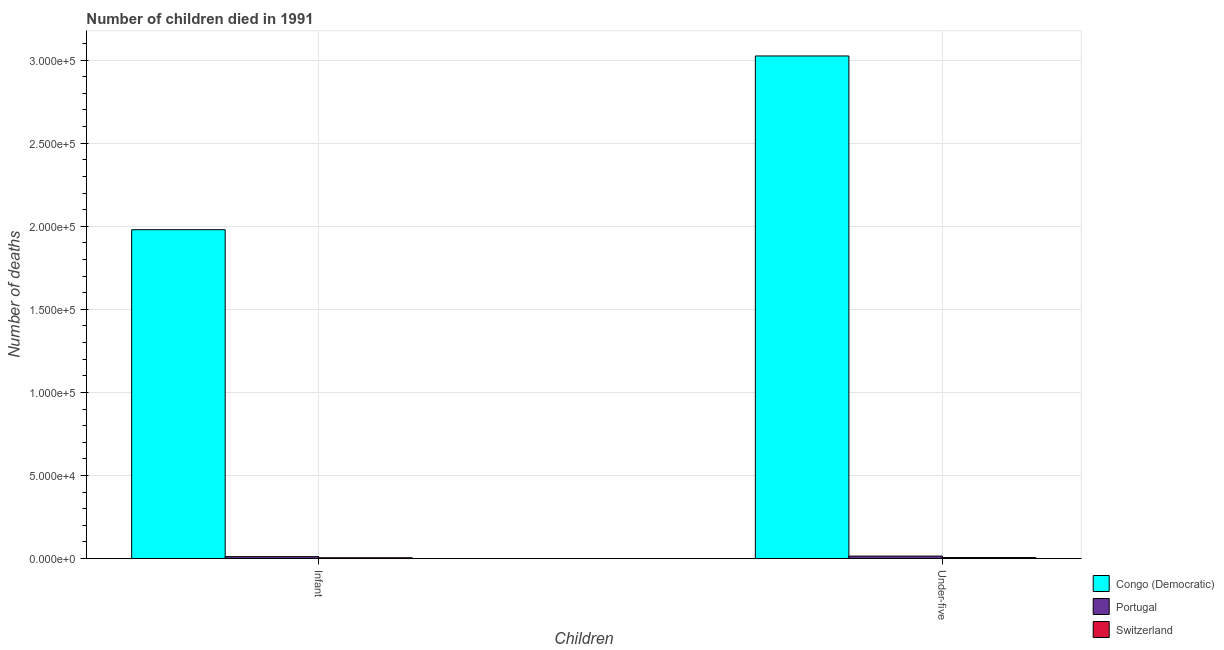How many different coloured bars are there?
Keep it short and to the point. 3. Are the number of bars on each tick of the X-axis equal?
Offer a very short reply. Yes. How many bars are there on the 1st tick from the left?
Provide a short and direct response. 3. How many bars are there on the 2nd tick from the right?
Make the answer very short. 3. What is the label of the 2nd group of bars from the left?
Your response must be concise. Under-five. What is the number of infant deaths in Switzerland?
Your response must be concise. 493. Across all countries, what is the maximum number of under-five deaths?
Provide a short and direct response. 3.03e+05. Across all countries, what is the minimum number of infant deaths?
Offer a terse response. 493. In which country was the number of under-five deaths maximum?
Give a very brief answer. Congo (Democratic). In which country was the number of under-five deaths minimum?
Your answer should be very brief. Switzerland. What is the total number of infant deaths in the graph?
Your answer should be compact. 2.00e+05. What is the difference between the number of infant deaths in Portugal and that in Congo (Democratic)?
Ensure brevity in your answer.  -1.97e+05. What is the difference between the number of under-five deaths in Congo (Democratic) and the number of infant deaths in Portugal?
Your answer should be compact. 3.01e+05. What is the average number of infant deaths per country?
Your answer should be very brief. 6.65e+04. What is the difference between the number of under-five deaths and number of infant deaths in Portugal?
Offer a terse response. 338. What is the ratio of the number of infant deaths in Portugal to that in Switzerland?
Offer a terse response. 2.34. Is the number of infant deaths in Portugal less than that in Switzerland?
Your answer should be very brief. No. In how many countries, is the number of infant deaths greater than the average number of infant deaths taken over all countries?
Offer a terse response. 1. What does the 1st bar from the right in Infant represents?
Your response must be concise. Switzerland. Are all the bars in the graph horizontal?
Your answer should be compact. No. Are the values on the major ticks of Y-axis written in scientific E-notation?
Provide a short and direct response. Yes. Does the graph contain grids?
Ensure brevity in your answer.  Yes. Where does the legend appear in the graph?
Make the answer very short. Bottom right. How many legend labels are there?
Ensure brevity in your answer.  3. What is the title of the graph?
Your response must be concise. Number of children died in 1991. What is the label or title of the X-axis?
Provide a short and direct response. Children. What is the label or title of the Y-axis?
Provide a short and direct response. Number of deaths. What is the Number of deaths in Congo (Democratic) in Infant?
Offer a very short reply. 1.98e+05. What is the Number of deaths in Portugal in Infant?
Your answer should be compact. 1156. What is the Number of deaths in Switzerland in Infant?
Offer a terse response. 493. What is the Number of deaths of Congo (Democratic) in Under-five?
Give a very brief answer. 3.03e+05. What is the Number of deaths in Portugal in Under-five?
Your answer should be very brief. 1494. What is the Number of deaths of Switzerland in Under-five?
Your answer should be very brief. 611. Across all Children, what is the maximum Number of deaths of Congo (Democratic)?
Keep it short and to the point. 3.03e+05. Across all Children, what is the maximum Number of deaths of Portugal?
Your answer should be very brief. 1494. Across all Children, what is the maximum Number of deaths of Switzerland?
Your response must be concise. 611. Across all Children, what is the minimum Number of deaths in Congo (Democratic)?
Your response must be concise. 1.98e+05. Across all Children, what is the minimum Number of deaths in Portugal?
Ensure brevity in your answer.  1156. Across all Children, what is the minimum Number of deaths of Switzerland?
Your answer should be compact. 493. What is the total Number of deaths in Congo (Democratic) in the graph?
Your answer should be very brief. 5.00e+05. What is the total Number of deaths in Portugal in the graph?
Your response must be concise. 2650. What is the total Number of deaths in Switzerland in the graph?
Your response must be concise. 1104. What is the difference between the Number of deaths in Congo (Democratic) in Infant and that in Under-five?
Give a very brief answer. -1.05e+05. What is the difference between the Number of deaths of Portugal in Infant and that in Under-five?
Your answer should be very brief. -338. What is the difference between the Number of deaths in Switzerland in Infant and that in Under-five?
Ensure brevity in your answer.  -118. What is the difference between the Number of deaths of Congo (Democratic) in Infant and the Number of deaths of Portugal in Under-five?
Keep it short and to the point. 1.96e+05. What is the difference between the Number of deaths of Congo (Democratic) in Infant and the Number of deaths of Switzerland in Under-five?
Provide a succinct answer. 1.97e+05. What is the difference between the Number of deaths of Portugal in Infant and the Number of deaths of Switzerland in Under-five?
Your response must be concise. 545. What is the average Number of deaths of Congo (Democratic) per Children?
Provide a succinct answer. 2.50e+05. What is the average Number of deaths in Portugal per Children?
Provide a short and direct response. 1325. What is the average Number of deaths in Switzerland per Children?
Offer a terse response. 552. What is the difference between the Number of deaths in Congo (Democratic) and Number of deaths in Portugal in Infant?
Offer a terse response. 1.97e+05. What is the difference between the Number of deaths of Congo (Democratic) and Number of deaths of Switzerland in Infant?
Your response must be concise. 1.97e+05. What is the difference between the Number of deaths of Portugal and Number of deaths of Switzerland in Infant?
Provide a short and direct response. 663. What is the difference between the Number of deaths in Congo (Democratic) and Number of deaths in Portugal in Under-five?
Make the answer very short. 3.01e+05. What is the difference between the Number of deaths of Congo (Democratic) and Number of deaths of Switzerland in Under-five?
Offer a terse response. 3.02e+05. What is the difference between the Number of deaths in Portugal and Number of deaths in Switzerland in Under-five?
Provide a succinct answer. 883. What is the ratio of the Number of deaths in Congo (Democratic) in Infant to that in Under-five?
Make the answer very short. 0.65. What is the ratio of the Number of deaths in Portugal in Infant to that in Under-five?
Provide a short and direct response. 0.77. What is the ratio of the Number of deaths in Switzerland in Infant to that in Under-five?
Provide a short and direct response. 0.81. What is the difference between the highest and the second highest Number of deaths of Congo (Democratic)?
Your response must be concise. 1.05e+05. What is the difference between the highest and the second highest Number of deaths of Portugal?
Offer a terse response. 338. What is the difference between the highest and the second highest Number of deaths in Switzerland?
Your answer should be very brief. 118. What is the difference between the highest and the lowest Number of deaths in Congo (Democratic)?
Offer a terse response. 1.05e+05. What is the difference between the highest and the lowest Number of deaths of Portugal?
Make the answer very short. 338. What is the difference between the highest and the lowest Number of deaths of Switzerland?
Keep it short and to the point. 118. 